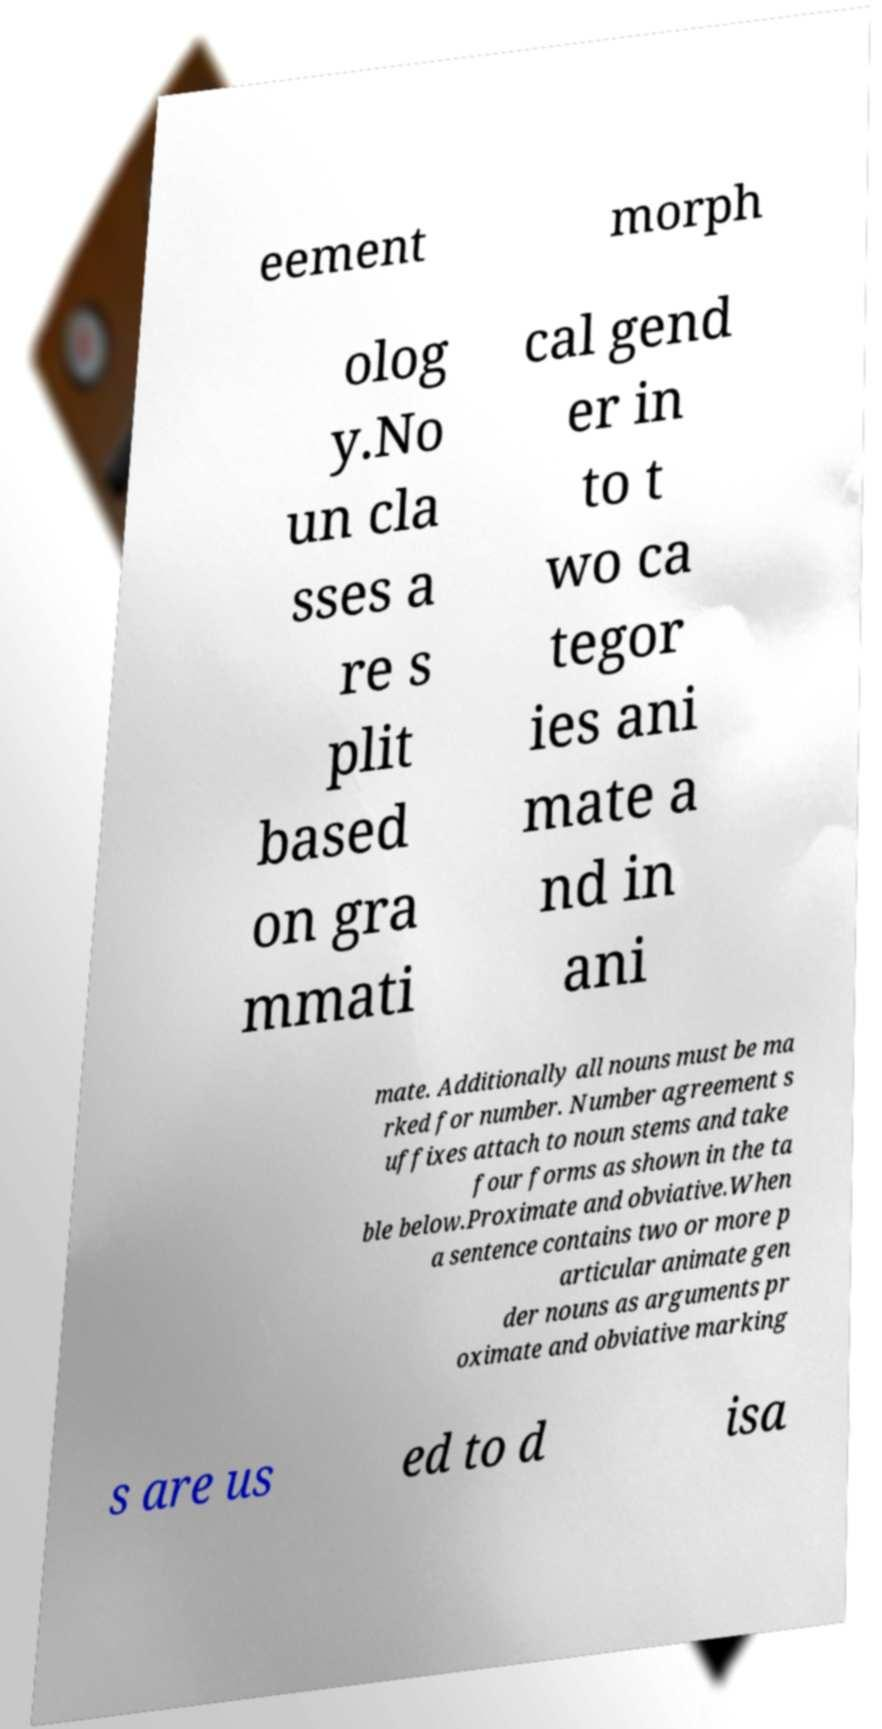I need the written content from this picture converted into text. Can you do that? eement morph olog y.No un cla sses a re s plit based on gra mmati cal gend er in to t wo ca tegor ies ani mate a nd in ani mate. Additionally all nouns must be ma rked for number. Number agreement s uffixes attach to noun stems and take four forms as shown in the ta ble below.Proximate and obviative.When a sentence contains two or more p articular animate gen der nouns as arguments pr oximate and obviative marking s are us ed to d isa 